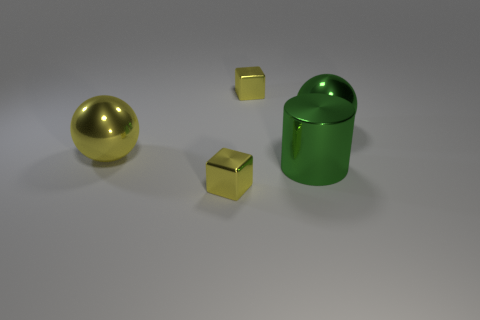Subtract all yellow spheres. How many spheres are left? 1 Subtract all cyan spheres. Subtract all purple blocks. How many spheres are left? 2 Subtract all purple cubes. How many cyan cylinders are left? 0 Subtract all small gray cubes. Subtract all big yellow metallic balls. How many objects are left? 4 Add 2 large green metal cylinders. How many large green metal cylinders are left? 3 Add 5 small cyan metallic cylinders. How many small cyan metallic cylinders exist? 5 Add 5 big blue rubber cylinders. How many objects exist? 10 Subtract 0 purple cylinders. How many objects are left? 5 Subtract all cylinders. How many objects are left? 4 Subtract 1 cylinders. How many cylinders are left? 0 